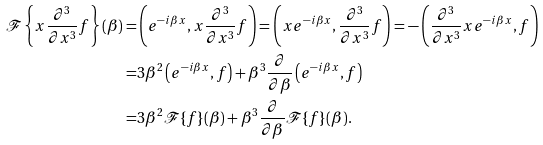Convert formula to latex. <formula><loc_0><loc_0><loc_500><loc_500>\mathcal { F } \left \{ x \frac { \partial ^ { 3 } } { \partial x ^ { 3 } } f \right \} ( \beta ) = & \left ( e ^ { - i \beta x } , x \frac { \partial ^ { 3 } } { \partial x ^ { 3 } } f \right ) = \left ( x e ^ { - i \beta x } , \frac { \partial ^ { 3 } } { \partial x ^ { 3 } } f \right ) = - \left ( \frac { \partial ^ { 3 } } { \partial x ^ { 3 } } x e ^ { - i \beta x } , f \right ) \\ = & 3 \beta ^ { 2 } \left ( e ^ { - i \beta x } , f \right ) + \beta ^ { 3 } \frac { \partial } { \partial \beta } \left ( e ^ { - i \beta x } , f \right ) \\ = & 3 \beta ^ { 2 } \mathcal { F } \{ f \} ( \beta ) + \beta ^ { 3 } \frac { \partial } { \partial \beta } \mathcal { F } \{ f \} ( \beta ) .</formula> 